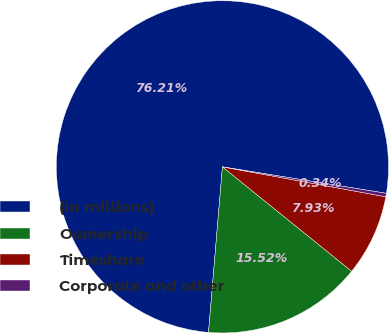<chart> <loc_0><loc_0><loc_500><loc_500><pie_chart><fcel>(in millions)<fcel>Ownership<fcel>Timeshare<fcel>Corporate and other<nl><fcel>76.21%<fcel>15.52%<fcel>7.93%<fcel>0.34%<nl></chart> 